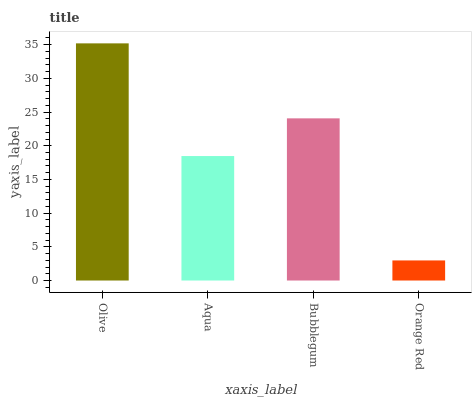Is Orange Red the minimum?
Answer yes or no. Yes. Is Olive the maximum?
Answer yes or no. Yes. Is Aqua the minimum?
Answer yes or no. No. Is Aqua the maximum?
Answer yes or no. No. Is Olive greater than Aqua?
Answer yes or no. Yes. Is Aqua less than Olive?
Answer yes or no. Yes. Is Aqua greater than Olive?
Answer yes or no. No. Is Olive less than Aqua?
Answer yes or no. No. Is Bubblegum the high median?
Answer yes or no. Yes. Is Aqua the low median?
Answer yes or no. Yes. Is Olive the high median?
Answer yes or no. No. Is Orange Red the low median?
Answer yes or no. No. 